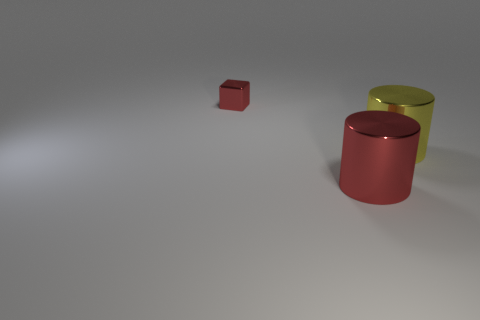Add 1 large blue shiny objects. How many objects exist? 4 Subtract all blocks. How many objects are left? 2 Subtract 0 gray cylinders. How many objects are left? 3 Subtract all cubes. Subtract all tiny red blocks. How many objects are left? 1 Add 3 metallic cubes. How many metallic cubes are left? 4 Add 1 tiny purple metal balls. How many tiny purple metal balls exist? 1 